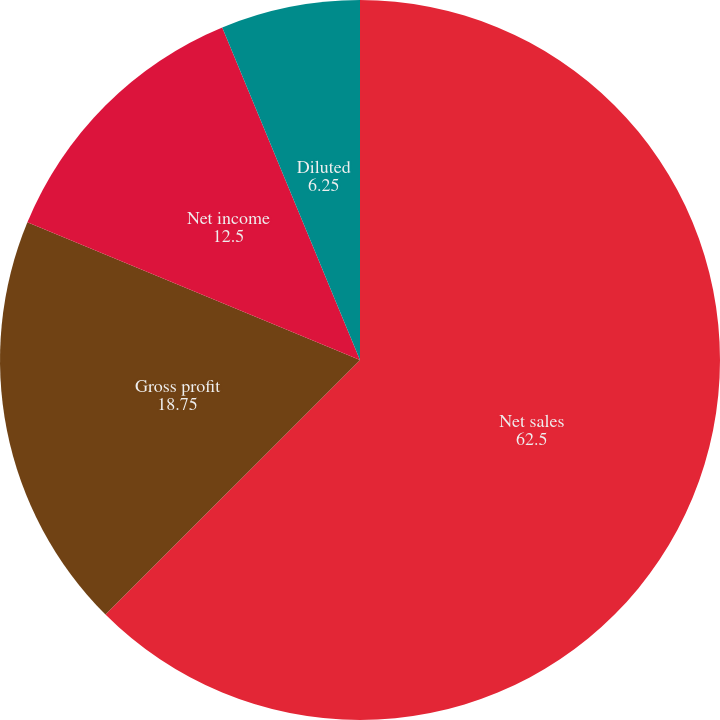Convert chart to OTSL. <chart><loc_0><loc_0><loc_500><loc_500><pie_chart><fcel>Net sales<fcel>Gross profit<fcel>Net income<fcel>Basic<fcel>Diluted<nl><fcel>62.5%<fcel>18.75%<fcel>12.5%<fcel>0.0%<fcel>6.25%<nl></chart> 